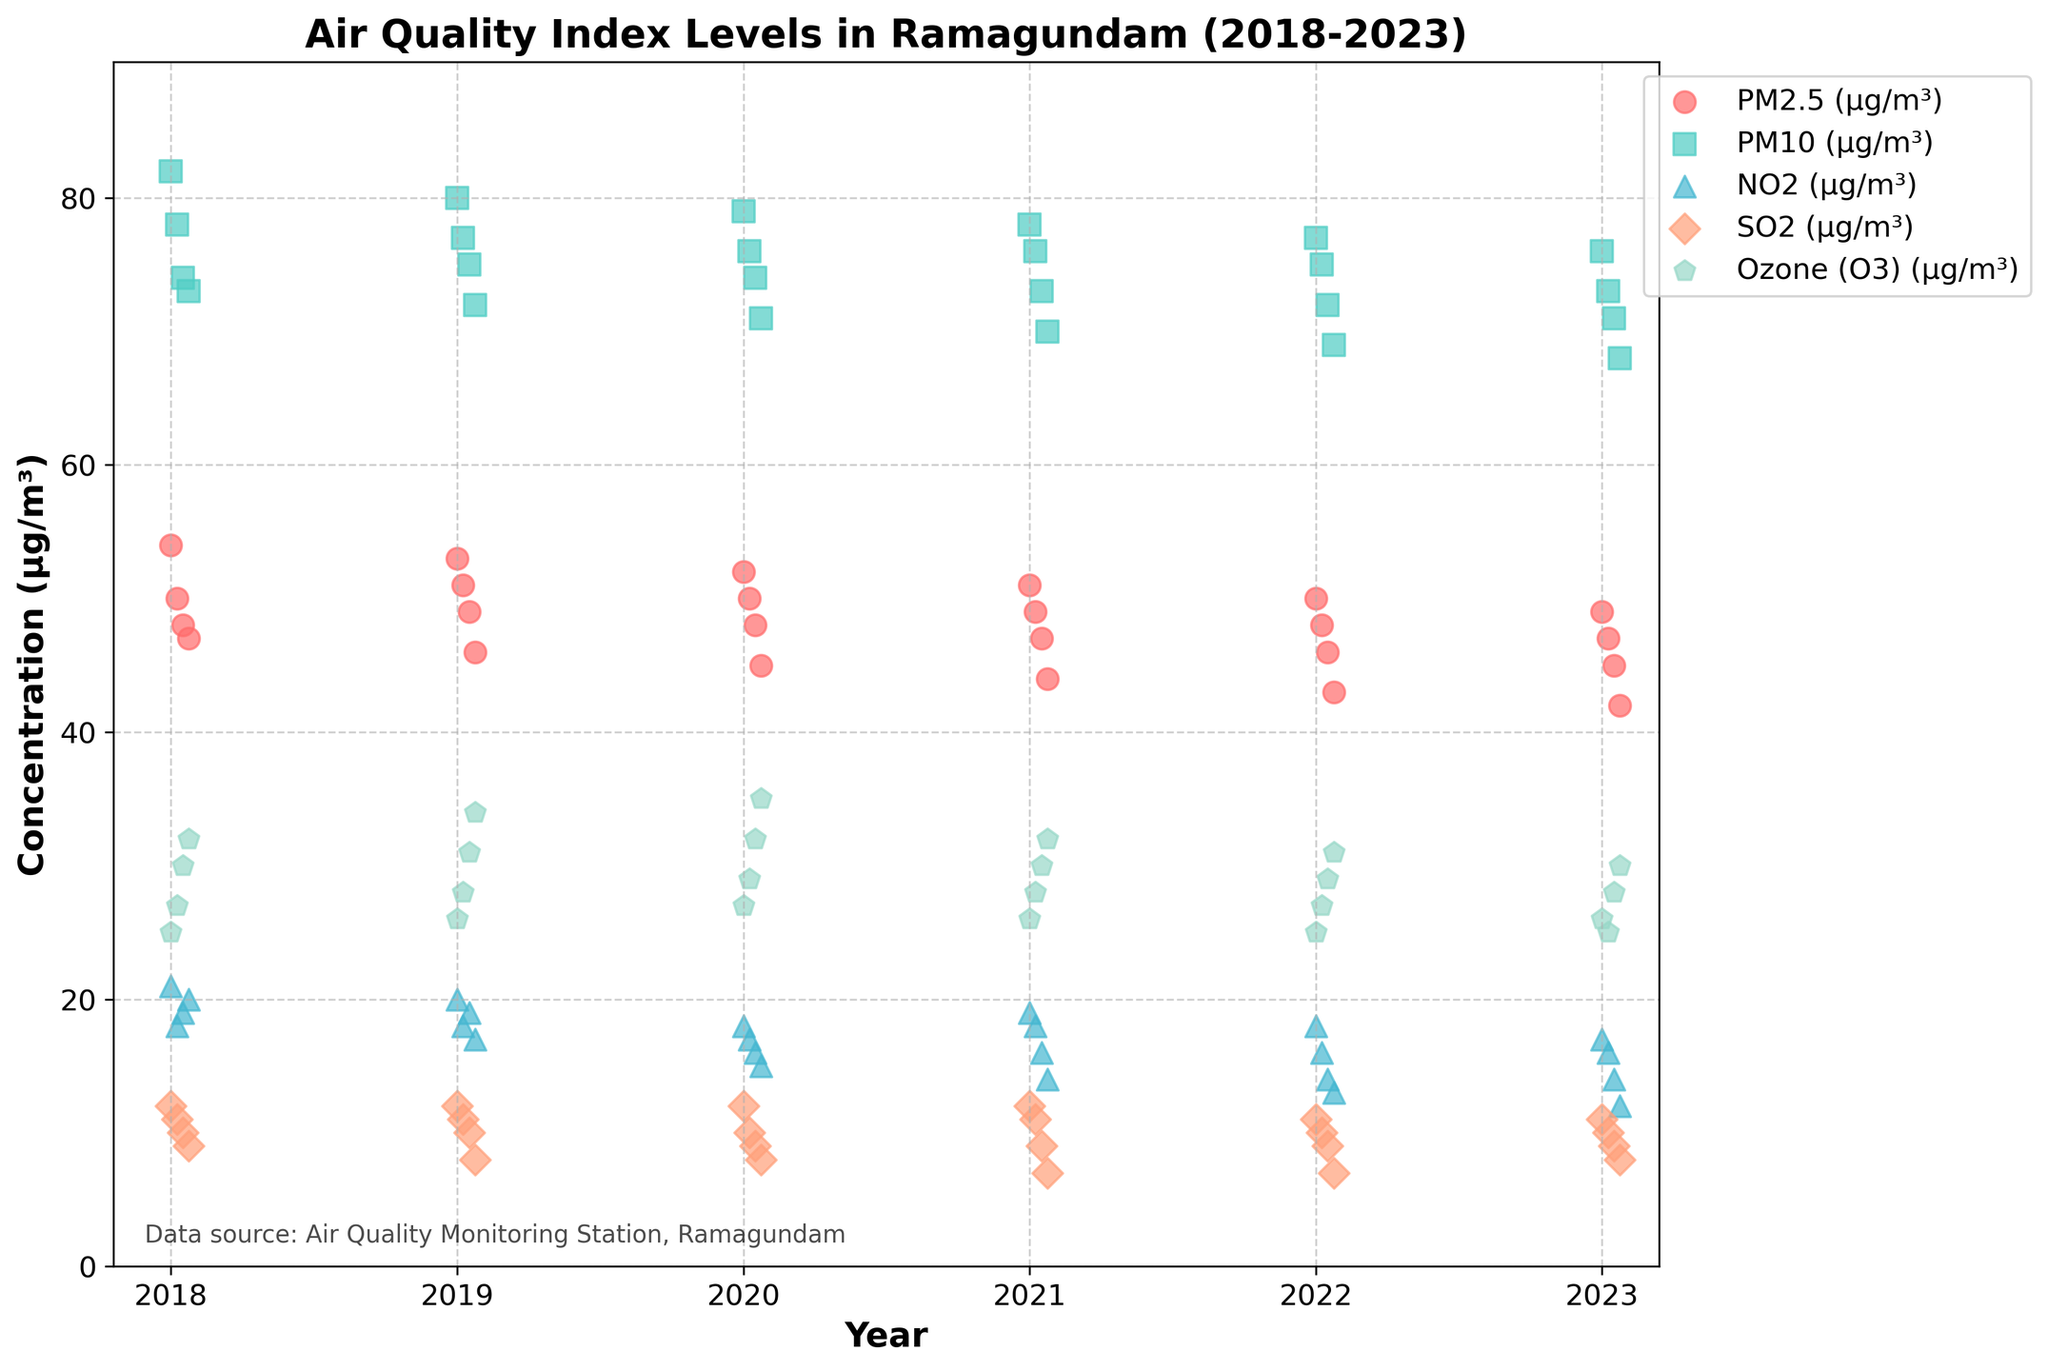What is the title of the plot? The title of the plot is usually displayed at the top of the figure and it summarizes the content of the visualization.
Answer: Air Quality Index Levels in Ramagundam (2018-2023) How many types of pollutants are shown in the plot? You can count the different labels in the legend of the plot to determine the types of pollutants shown.
Answer: 5 Can you list the different types of pollutants displayed in the plot? The different types of pollutants are indicated by the labels in the legend.
Answer: PM2.5, PM10, NO2, SO2, Ozone Which pollutant had the highest peak concentration and in which year/month? By examining the scatter plot, you can identify the highest data point and see which pollutant it corresponds to along with its year/month.
Answer: PM10, January 2018 How does the concentration of PM2.5 change from January 2018 to April 2023? Track the data points for PM2.5 (indicated by its specific marker and color) from January 2018 to April 2023 and observe the trend.
Answer: Decreases Which month in 2022 had the lowest concentration of NO2? Look specifically at the NO2 data points for the year 2022 and identify the month with the lowest concentration.
Answer: April Did the concentration of SO2 show an increasing or decreasing trend over the observed years? By connecting the SO2 data points from 2018 to 2023, you can observe the general trend to see if it increased or decreased.
Answer: Decreasing Compare the concentration of Ozone in January 2019 and January 2023. Which year had a higher concentration? Locate the data points for Ozone in January 2019 and January 2023 and compare their values.
Answer: January 2019 What is the average concentration of PM10 over the five years? Sum the PM10 concentration values for each data point provided for the five years and divide by the number of data points.
Answer: 74.75 Which month consistently shows the highest air pollution for PM10 across the years? By looking at the PM10 data points for each month for all the years, identify which month generally has the highest concentration.
Answer: January 